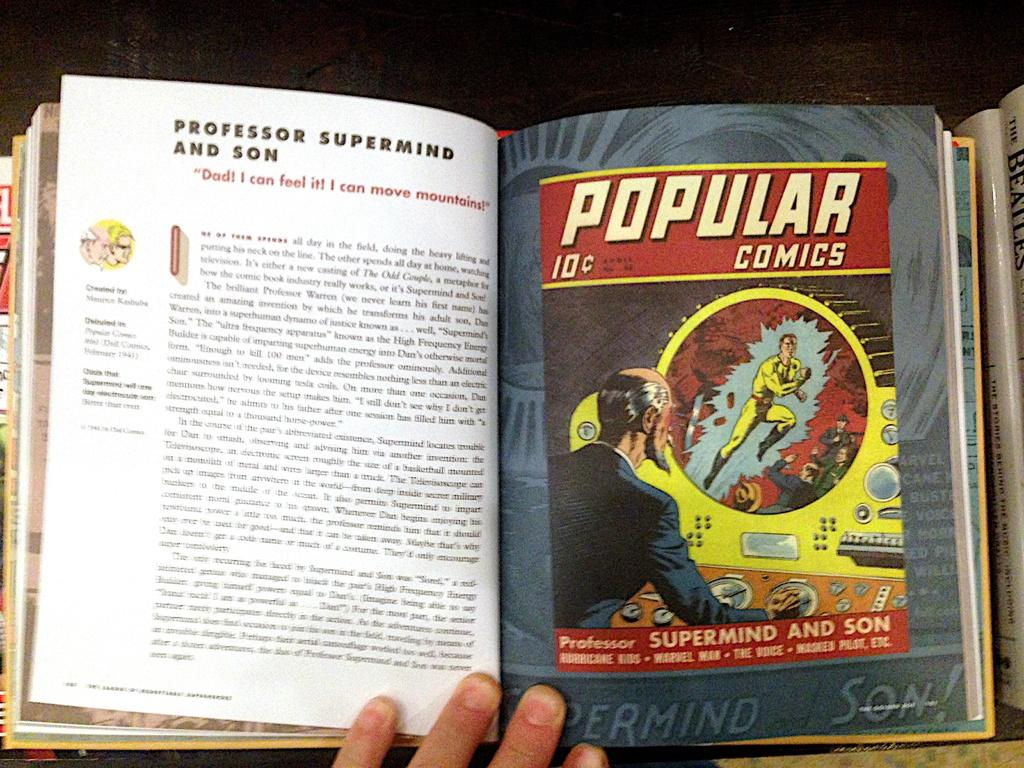<image>
Share a concise interpretation of the image provided. A book displaying different comic book covers such as Professor Supermind and Son. 